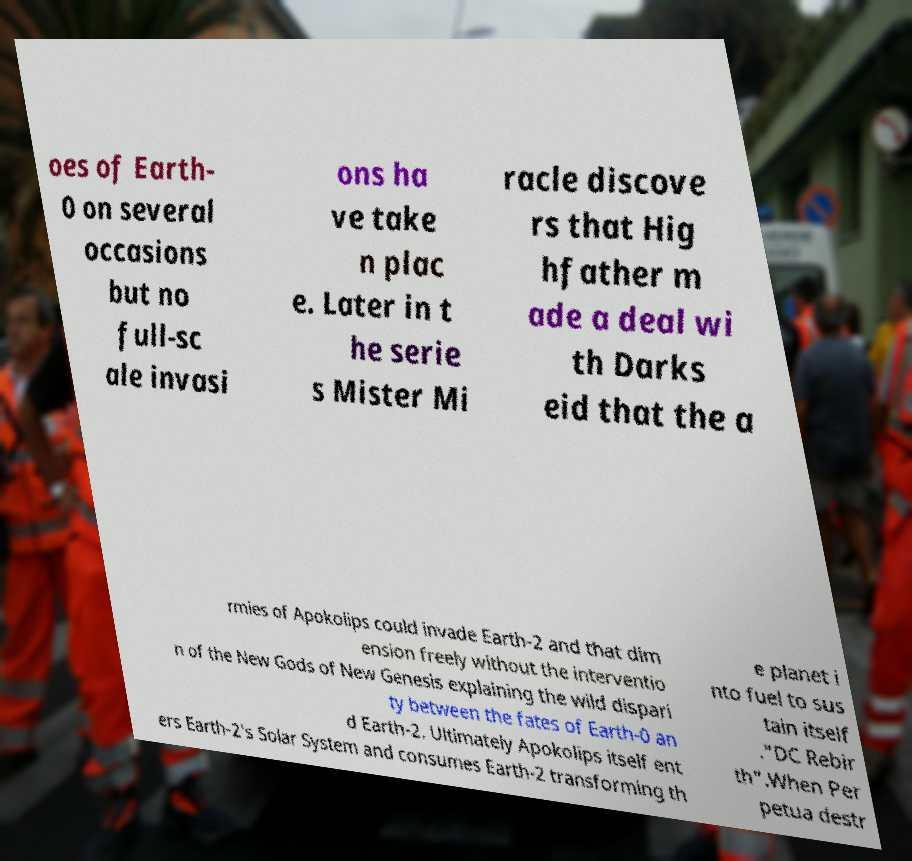Can you accurately transcribe the text from the provided image for me? oes of Earth- 0 on several occasions but no full-sc ale invasi ons ha ve take n plac e. Later in t he serie s Mister Mi racle discove rs that Hig hfather m ade a deal wi th Darks eid that the a rmies of Apokolips could invade Earth-2 and that dim ension freely without the interventio n of the New Gods of New Genesis explaining the wild dispari ty between the fates of Earth-0 an d Earth-2. Ultimately Apokolips itself ent ers Earth-2's Solar System and consumes Earth-2 transforming th e planet i nto fuel to sus tain itself ."DC Rebir th".When Per petua destr 